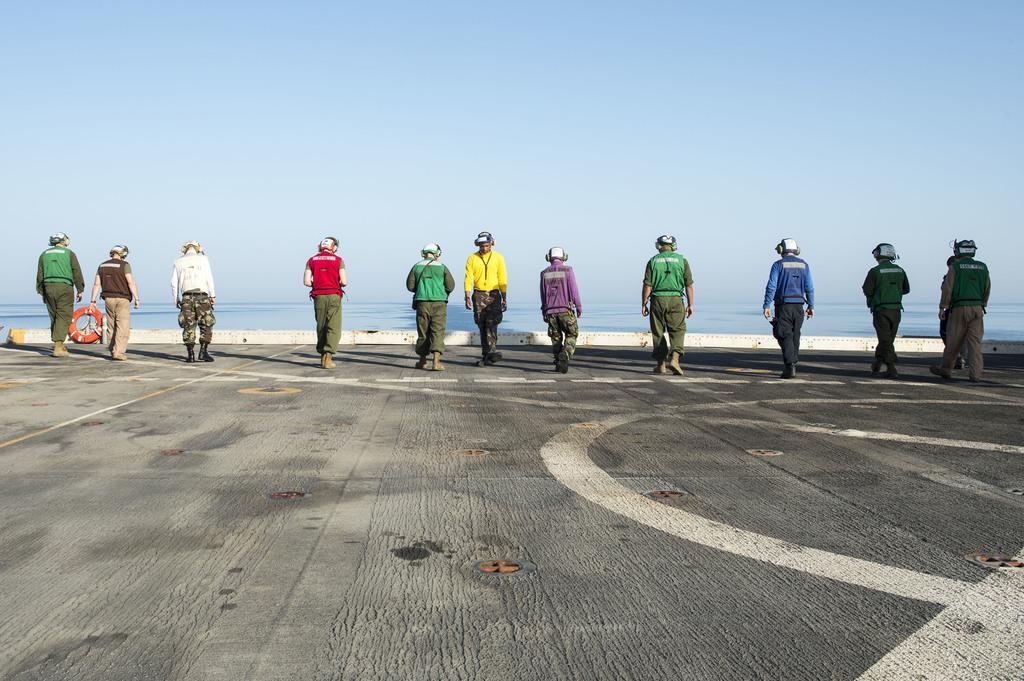In one or two sentences, can you explain what this image depicts? This picture is clicked outside. In the center we can see the group of people wearing helmets and walking on the ground. In the background we can see the sky and an object seems to be a water body. 